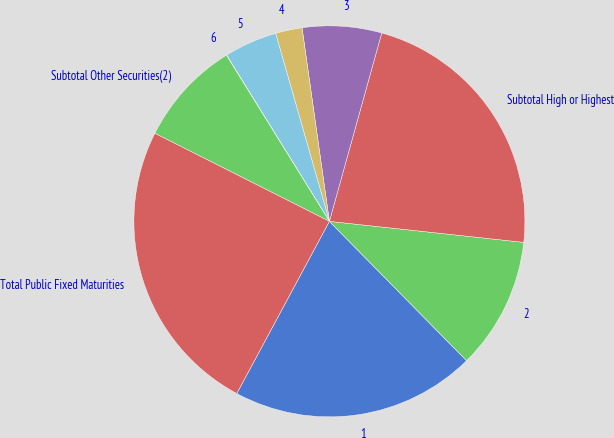Convert chart to OTSL. <chart><loc_0><loc_0><loc_500><loc_500><pie_chart><fcel>1<fcel>2<fcel>Subtotal High or Highest<fcel>3<fcel>4<fcel>5<fcel>6<fcel>Subtotal Other Securities(2)<fcel>Total Public Fixed Maturities<nl><fcel>20.23%<fcel>10.91%<fcel>22.4%<fcel>6.55%<fcel>2.2%<fcel>4.38%<fcel>0.02%<fcel>8.73%<fcel>24.58%<nl></chart> 